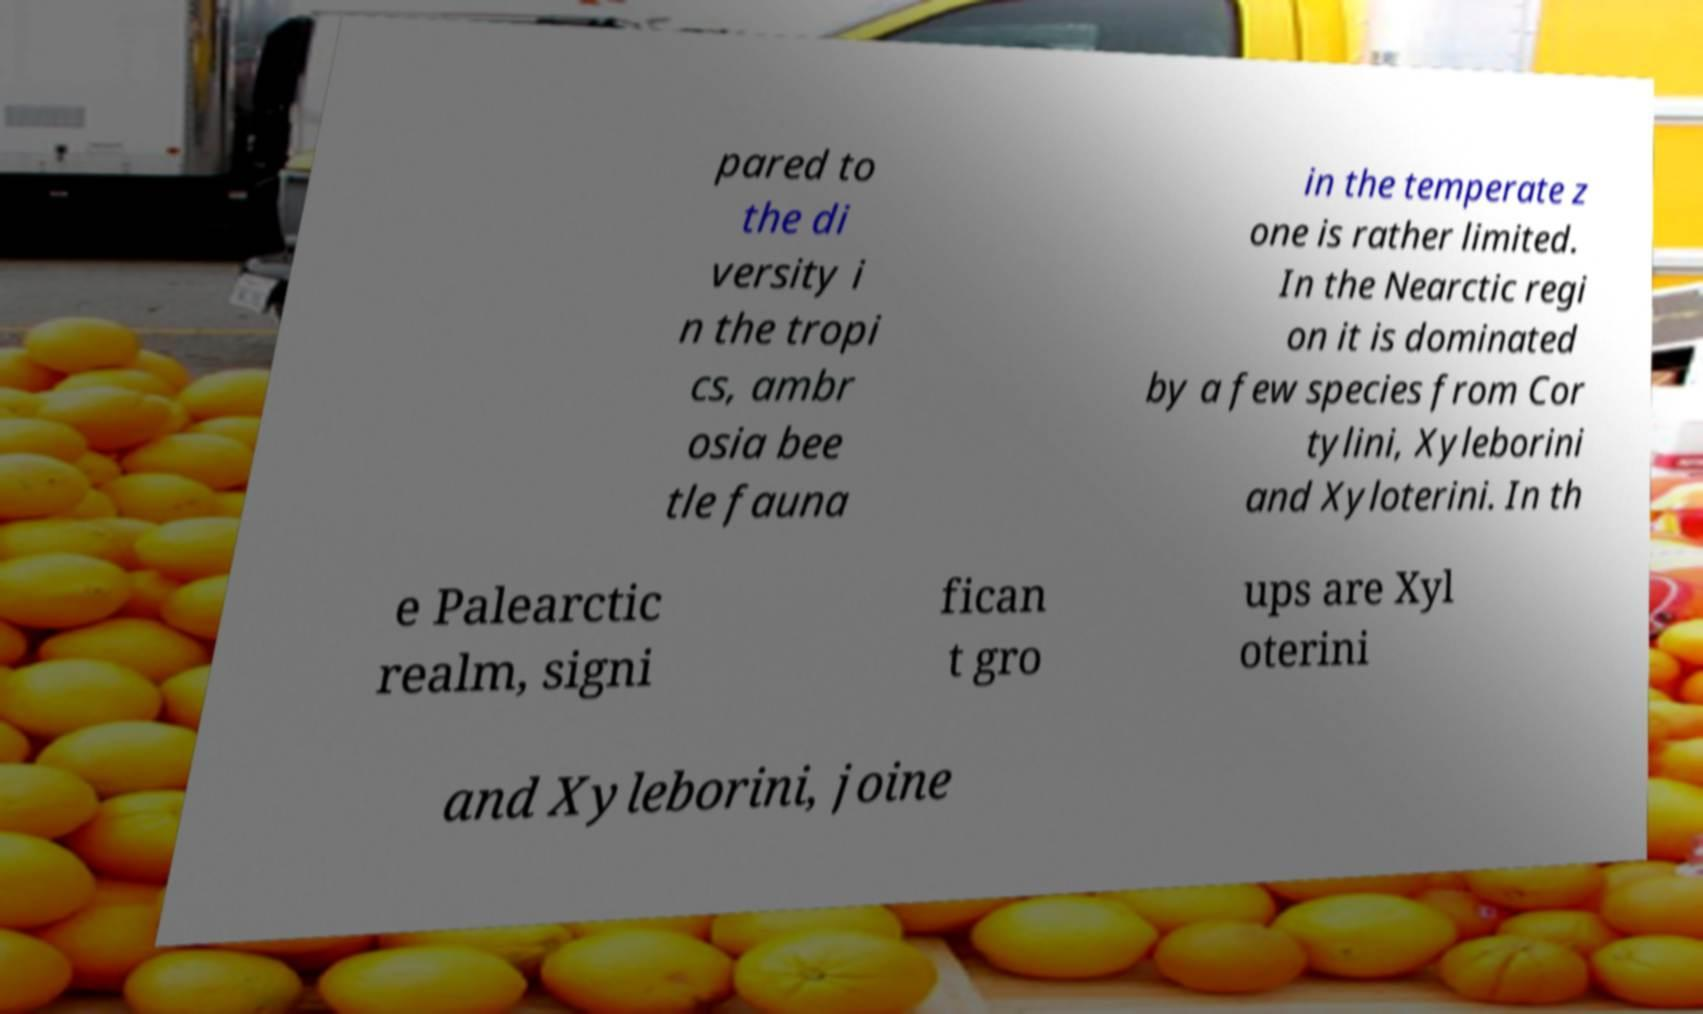Could you extract and type out the text from this image? pared to the di versity i n the tropi cs, ambr osia bee tle fauna in the temperate z one is rather limited. In the Nearctic regi on it is dominated by a few species from Cor tylini, Xyleborini and Xyloterini. In th e Palearctic realm, signi fican t gro ups are Xyl oterini and Xyleborini, joine 